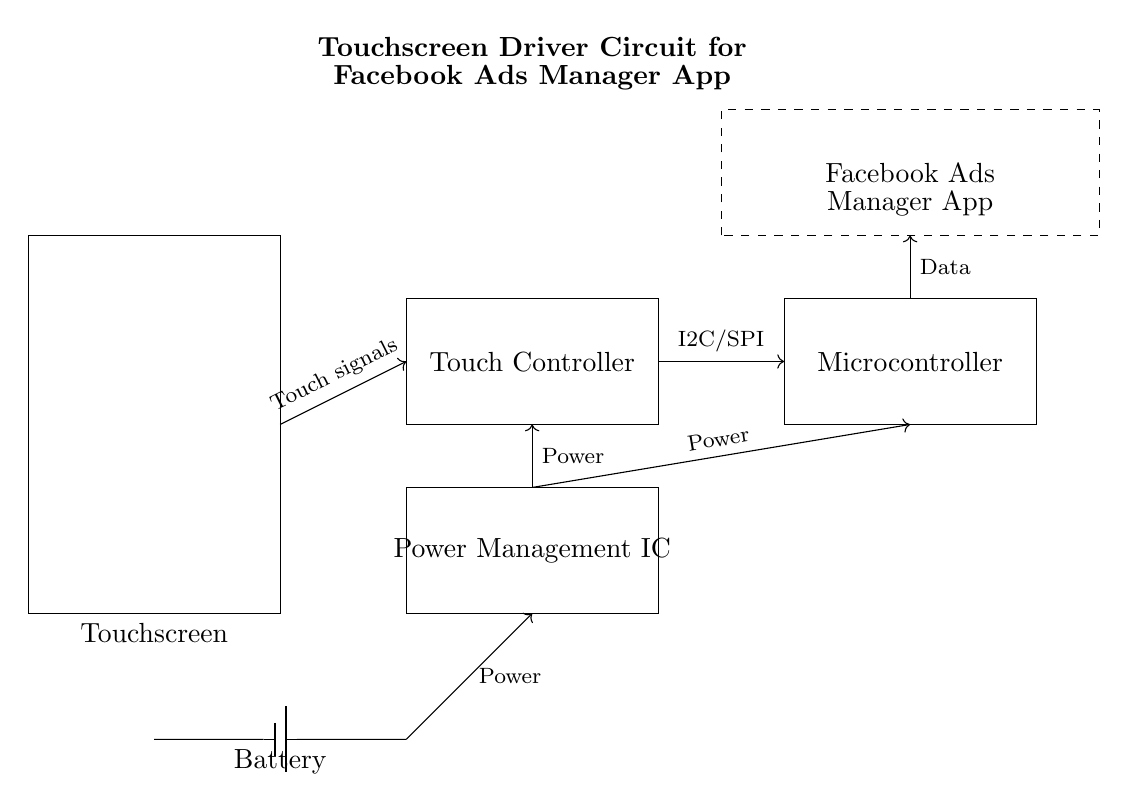What components are present in this circuit? The components in the circuit include a touchscreen, a touch controller, a microcontroller, a power management IC, and a battery. These are all shown in rectangular boxes in the diagram with labels.
Answer: touchscreen, touch controller, microcontroller, power management IC, battery What is the primary function of the power management IC? The power management IC is responsible for regulating and distributing power to the various components in the circuit such as the touchscreen and the microcontroller. It ensures that each component receives the correct voltage for optimal operation.
Answer: Power regulation What type of communication is used between the touch controller and the microcontroller? The touch controller communicates with the microcontroller using I2C/SPI protocols, which are indicated in the diagram by the labeled arrow connecting these two components.
Answer: I2C/SPI How is the battery connected in the circuit? The battery is connected to the power management IC, which is shown by the line leading from the battery to the power management IC, indicating the flow of power in the circuit.
Answer: Connected to power management IC What data does the microcontroller send to the Facebook Ads Manager app? The microcontroller sends data to the Facebook Ads Manager app, which is indicated by the arrow connecting these two components in the diagram, labeled "Data." This data likely represents touch events processed by the microcontroller for interactions within the app.
Answer: Touch event data What is the purpose of the touchscreen in this circuit? The touchscreen serves as the input interface for the user to interact with the Facebook Ads Manager app, allowing for precise selection and manipulation of elements on the screen as indicated by its location at the front of the circuit diagram.
Answer: User interaction interface What type of power source does this circuit utilize? This circuit utilizes a battery as the power source, indicated by the battery symbol in the diagram at the bottom, connecting to the power management IC. It provides the necessary energy to operate the other components.
Answer: Battery 